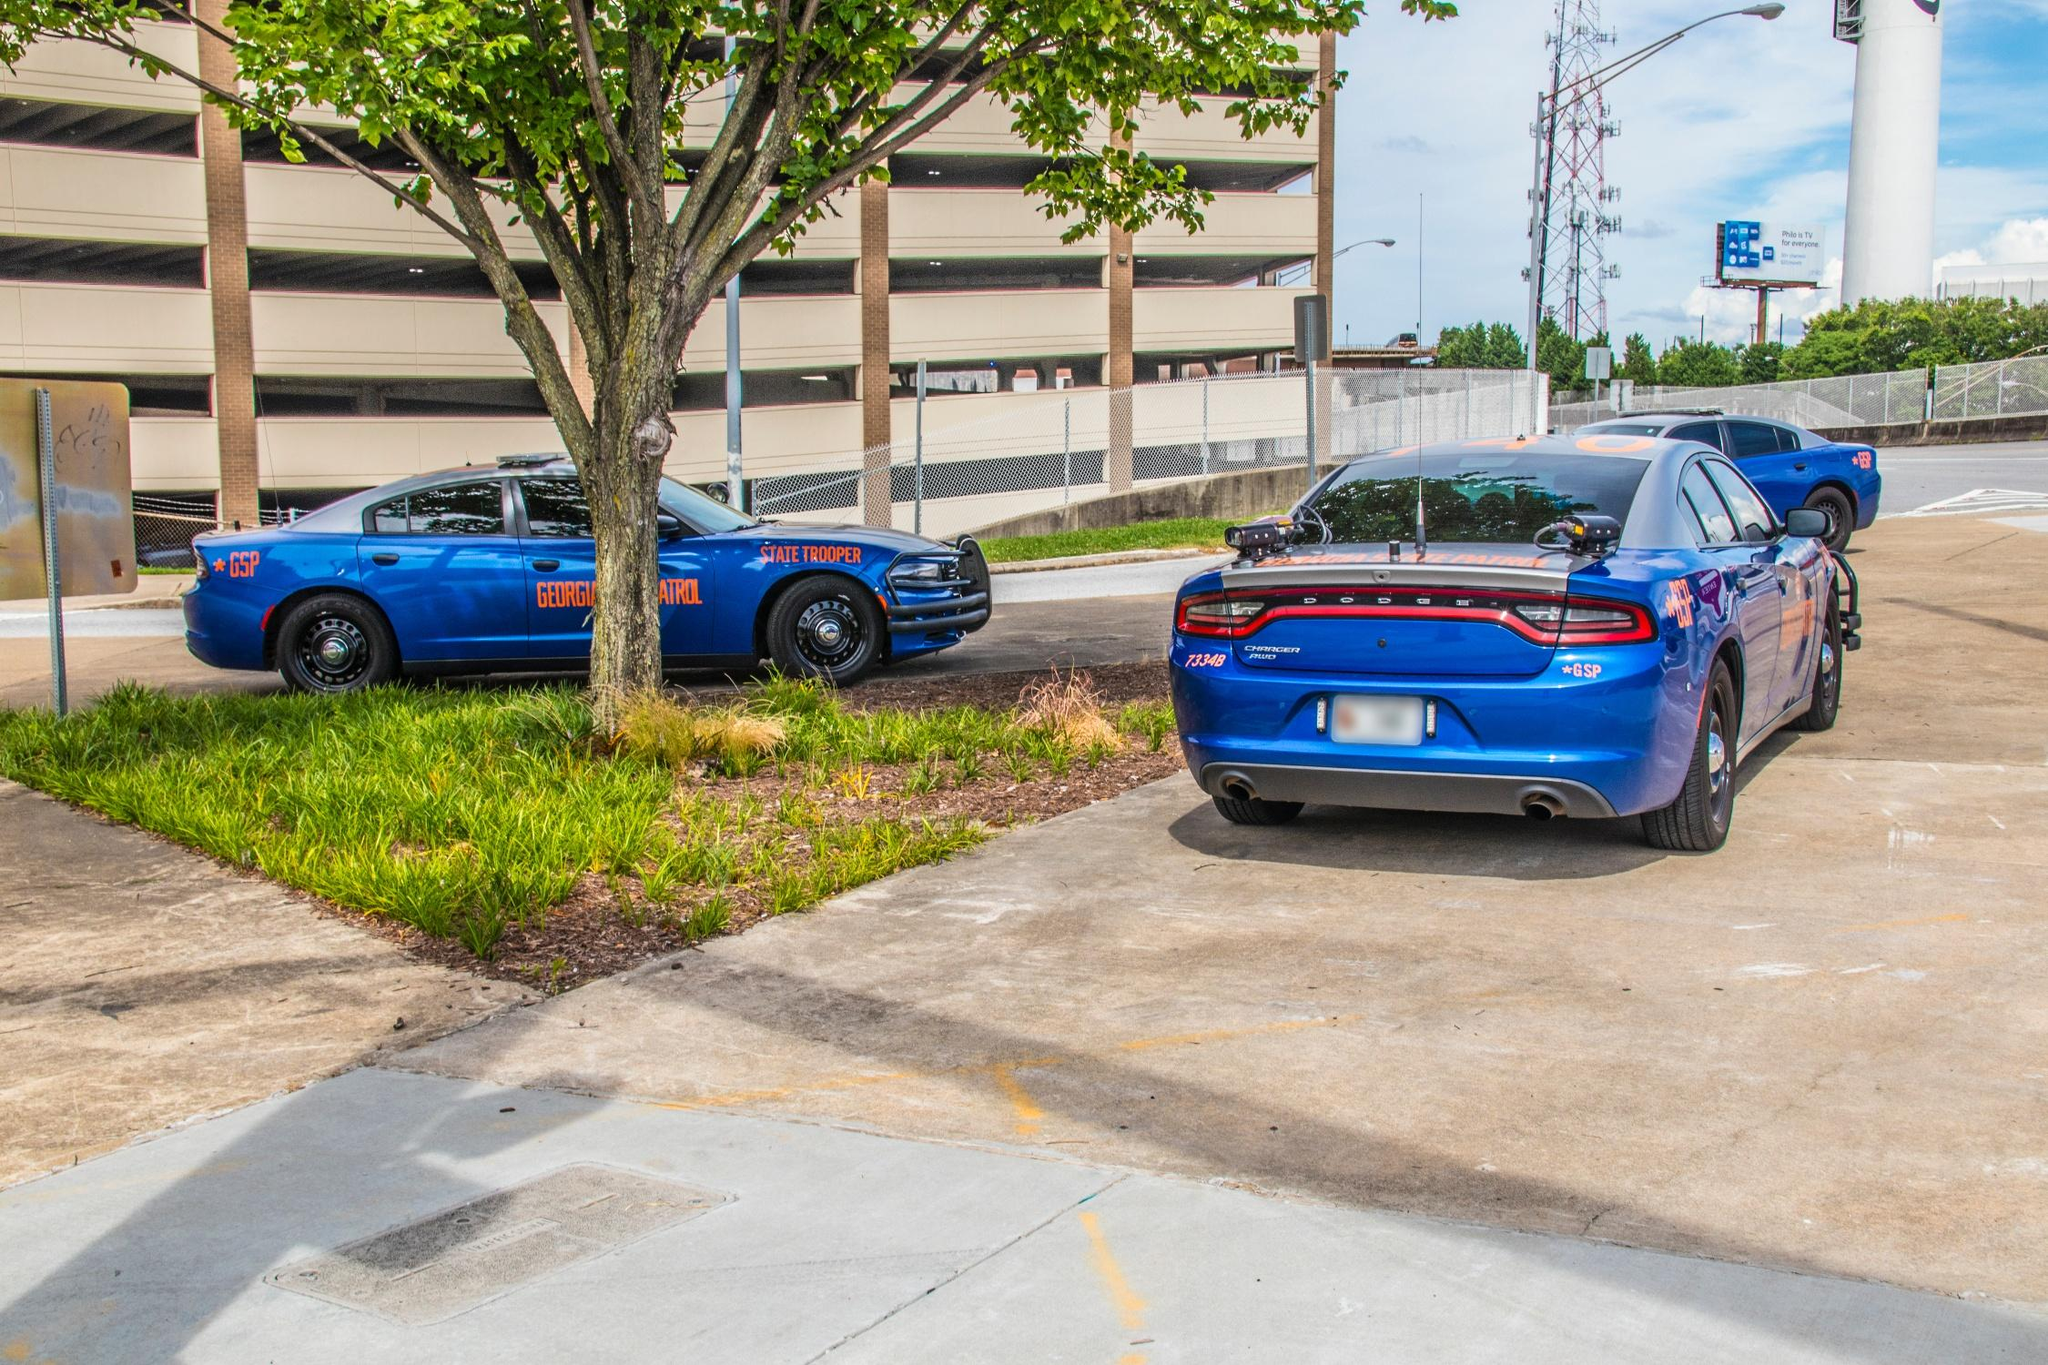Analyze the image in a comprehensive and detailed manner. The image captures a day in the life of the Georgia State Patrol, with two of their vibrant blue units parked in a lot. On the left, a Dodge Charger marked with 'GSP' and 'Georgia State Trooper' indicates its affiliation clearly. On the right, another Charger, highlighted with 'K-9 UNIT' text, suggests it's special for canine operations. These vehicles, equipped with special law enforcement lights and push bumpers, are strategically parked outside what seems to be a layered parking facility likely related to city or state infrastructure. The environment around the cars includes a small, well-maintained green space with a single tree, providing a contrast to the technological and human-made elements present. The backdrop partially includes an urban setting with hints of a communication tower, suggesting a connection to broader state communication networks essential for law enforcement. This scene not only reflects the readiness of law enforcement but also shows their integration into the community they serve. 